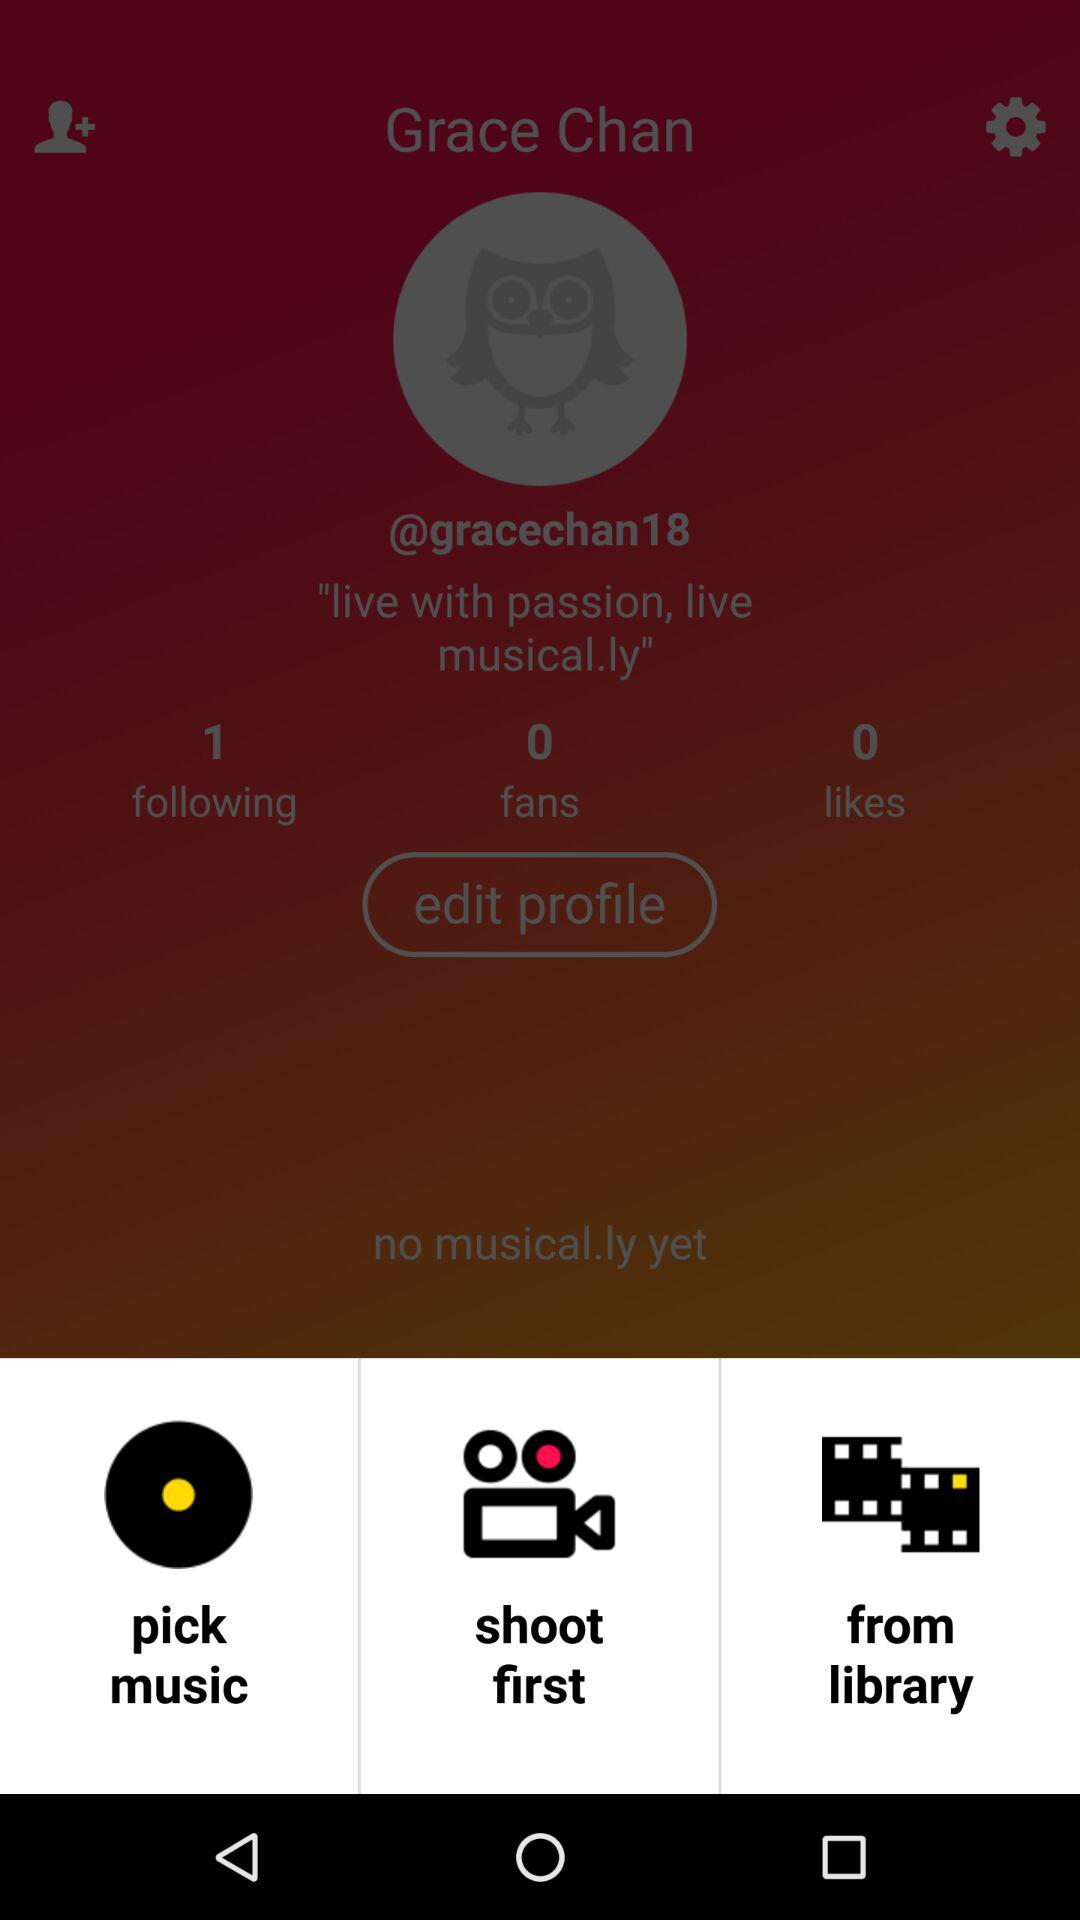How many musical.lys does Grace Chan have?
Answer the question using a single word or phrase. 0 